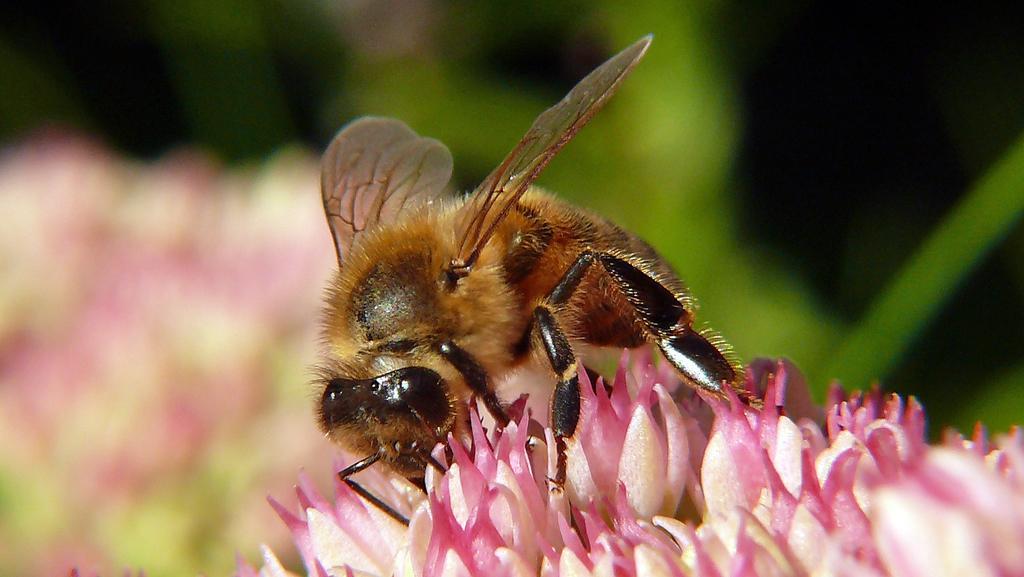Could you give a brief overview of what you see in this image? In this picture I can see an insect on the flowers, and there is blur background. 